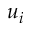Convert formula to latex. <formula><loc_0><loc_0><loc_500><loc_500>u _ { i }</formula> 